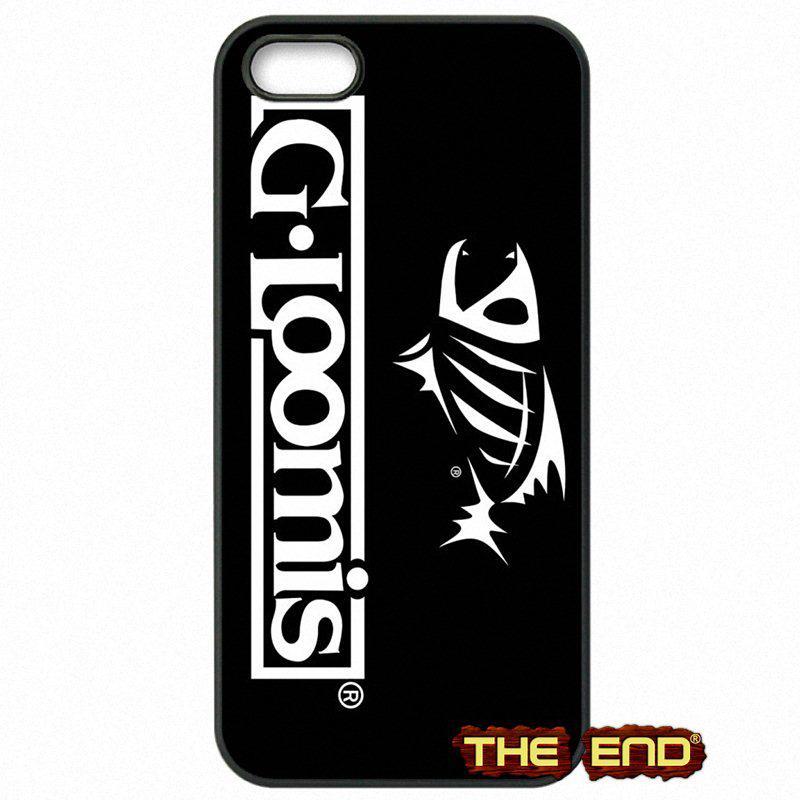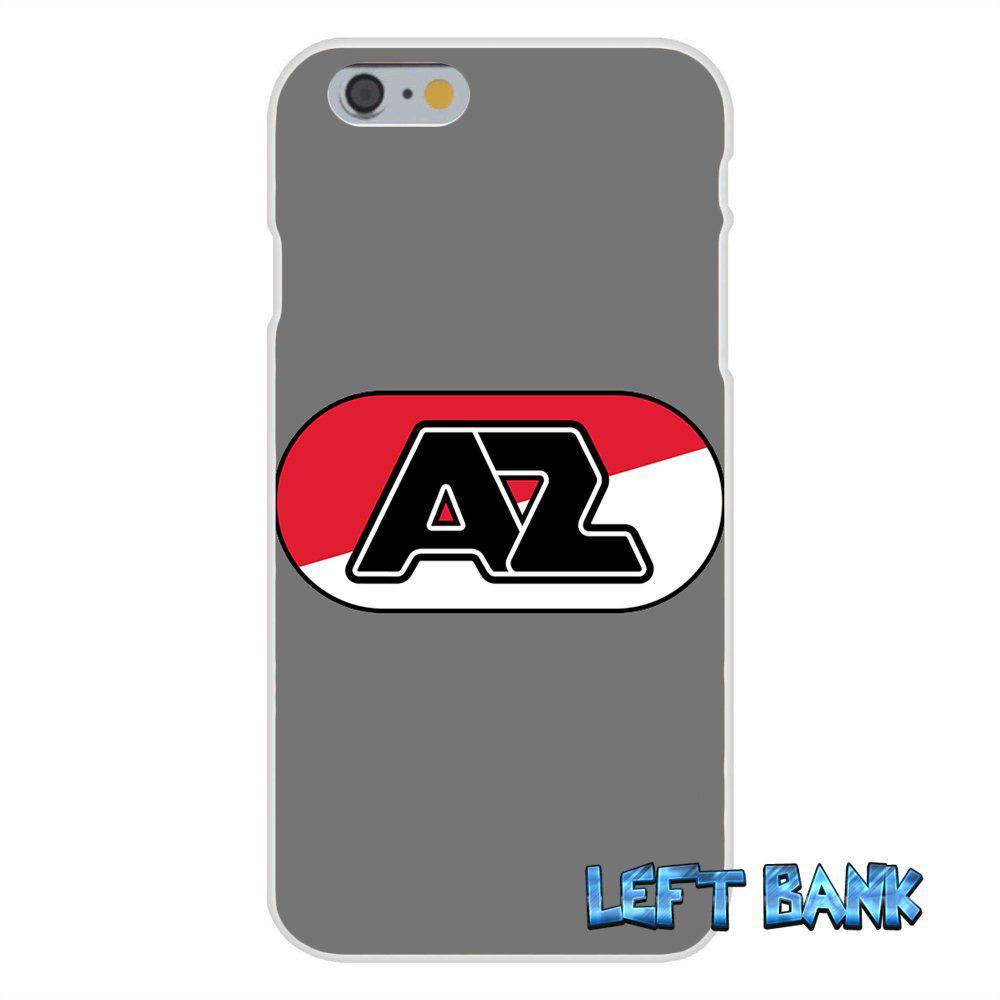The first image is the image on the left, the second image is the image on the right. Examine the images to the left and right. Is the description "Each image in the pair shows multiple views of a mobile device." accurate? Answer yes or no. No. The first image is the image on the left, the second image is the image on the right. Considering the images on both sides, is "The combined images include at least one side view of a device, at least two front views of a device with an image on the screen, and at least one head-on view of the back of a device." valid? Answer yes or no. No. 